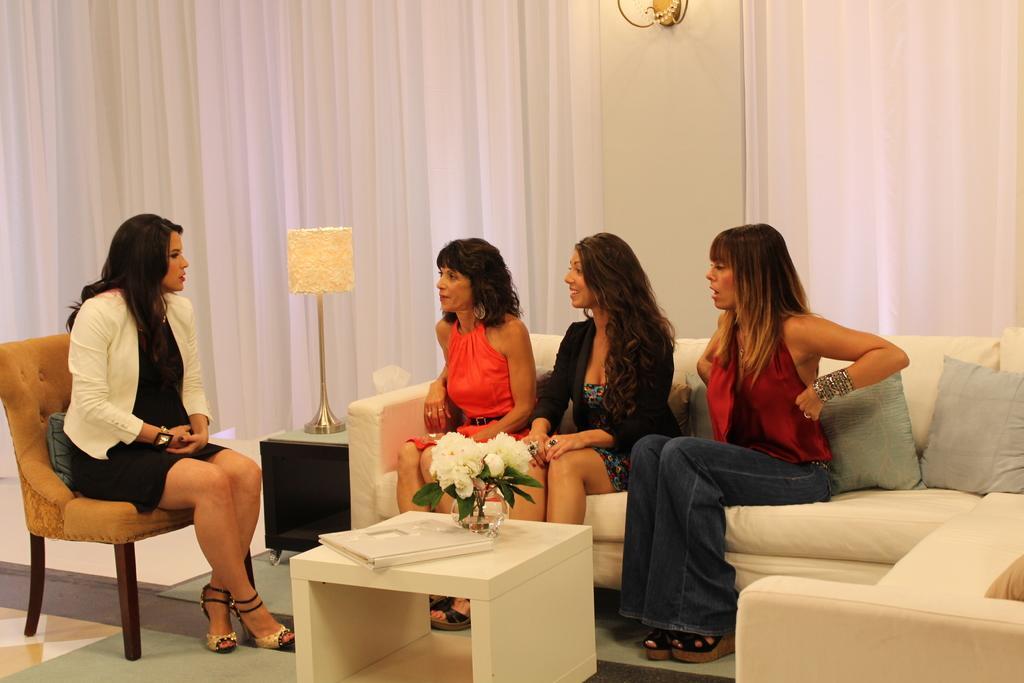Could you give a brief overview of what you see in this image? In this picture we can see four woman where three are sitting on sofa pillows on it and one is sitting on chair and talking to each of them and in front of them there is table and on table we can see book, vase with flower, lamp and in background we can see white color curtains. 